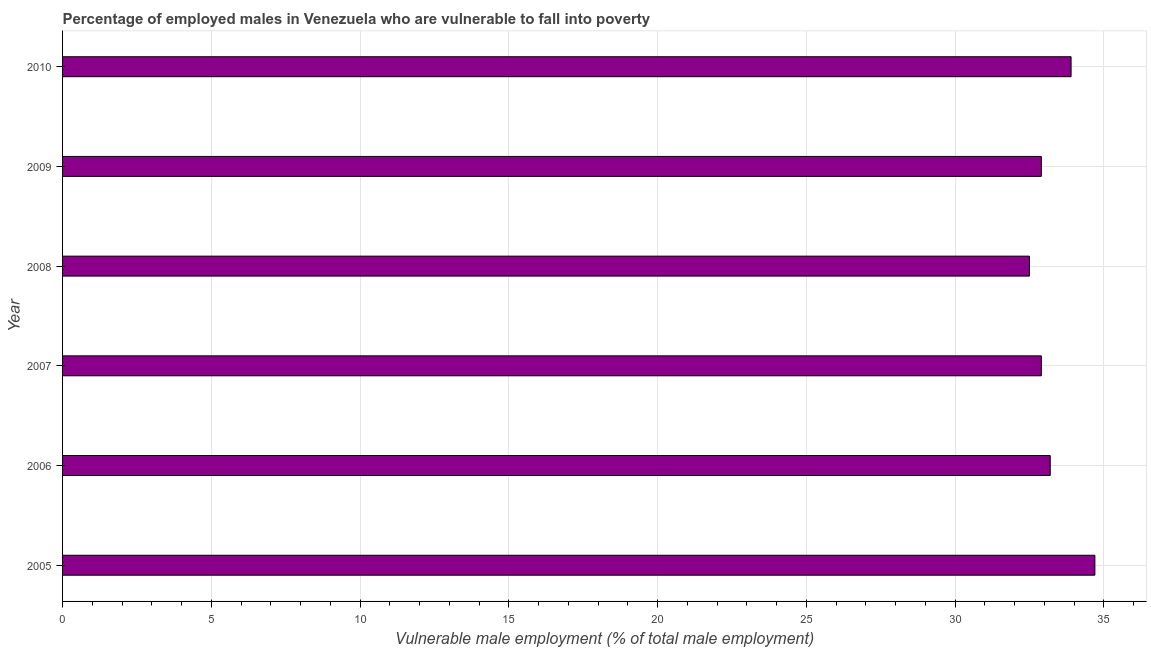Does the graph contain any zero values?
Offer a terse response. No. What is the title of the graph?
Ensure brevity in your answer.  Percentage of employed males in Venezuela who are vulnerable to fall into poverty. What is the label or title of the X-axis?
Provide a succinct answer. Vulnerable male employment (% of total male employment). What is the label or title of the Y-axis?
Provide a short and direct response. Year. What is the percentage of employed males who are vulnerable to fall into poverty in 2010?
Keep it short and to the point. 33.9. Across all years, what is the maximum percentage of employed males who are vulnerable to fall into poverty?
Your answer should be very brief. 34.7. Across all years, what is the minimum percentage of employed males who are vulnerable to fall into poverty?
Your response must be concise. 32.5. In which year was the percentage of employed males who are vulnerable to fall into poverty maximum?
Your response must be concise. 2005. In which year was the percentage of employed males who are vulnerable to fall into poverty minimum?
Give a very brief answer. 2008. What is the sum of the percentage of employed males who are vulnerable to fall into poverty?
Your answer should be compact. 200.1. What is the difference between the percentage of employed males who are vulnerable to fall into poverty in 2006 and 2010?
Provide a succinct answer. -0.7. What is the average percentage of employed males who are vulnerable to fall into poverty per year?
Offer a very short reply. 33.35. What is the median percentage of employed males who are vulnerable to fall into poverty?
Your response must be concise. 33.05. In how many years, is the percentage of employed males who are vulnerable to fall into poverty greater than 21 %?
Your answer should be compact. 6. Do a majority of the years between 2009 and 2007 (inclusive) have percentage of employed males who are vulnerable to fall into poverty greater than 19 %?
Your response must be concise. Yes. Is the difference between the percentage of employed males who are vulnerable to fall into poverty in 2009 and 2010 greater than the difference between any two years?
Give a very brief answer. No. Is the sum of the percentage of employed males who are vulnerable to fall into poverty in 2006 and 2008 greater than the maximum percentage of employed males who are vulnerable to fall into poverty across all years?
Your answer should be very brief. Yes. What is the difference between the highest and the lowest percentage of employed males who are vulnerable to fall into poverty?
Provide a short and direct response. 2.2. In how many years, is the percentage of employed males who are vulnerable to fall into poverty greater than the average percentage of employed males who are vulnerable to fall into poverty taken over all years?
Provide a short and direct response. 2. How many years are there in the graph?
Make the answer very short. 6. What is the difference between two consecutive major ticks on the X-axis?
Offer a very short reply. 5. What is the Vulnerable male employment (% of total male employment) of 2005?
Keep it short and to the point. 34.7. What is the Vulnerable male employment (% of total male employment) of 2006?
Ensure brevity in your answer.  33.2. What is the Vulnerable male employment (% of total male employment) of 2007?
Give a very brief answer. 32.9. What is the Vulnerable male employment (% of total male employment) of 2008?
Offer a very short reply. 32.5. What is the Vulnerable male employment (% of total male employment) in 2009?
Your response must be concise. 32.9. What is the Vulnerable male employment (% of total male employment) of 2010?
Your answer should be very brief. 33.9. What is the difference between the Vulnerable male employment (% of total male employment) in 2005 and 2006?
Provide a short and direct response. 1.5. What is the difference between the Vulnerable male employment (% of total male employment) in 2005 and 2007?
Offer a terse response. 1.8. What is the difference between the Vulnerable male employment (% of total male employment) in 2005 and 2008?
Provide a short and direct response. 2.2. What is the difference between the Vulnerable male employment (% of total male employment) in 2007 and 2008?
Offer a terse response. 0.4. What is the difference between the Vulnerable male employment (% of total male employment) in 2007 and 2010?
Offer a terse response. -1. What is the difference between the Vulnerable male employment (% of total male employment) in 2008 and 2009?
Your answer should be compact. -0.4. What is the difference between the Vulnerable male employment (% of total male employment) in 2008 and 2010?
Your answer should be compact. -1.4. What is the ratio of the Vulnerable male employment (% of total male employment) in 2005 to that in 2006?
Your answer should be very brief. 1.04. What is the ratio of the Vulnerable male employment (% of total male employment) in 2005 to that in 2007?
Make the answer very short. 1.05. What is the ratio of the Vulnerable male employment (% of total male employment) in 2005 to that in 2008?
Make the answer very short. 1.07. What is the ratio of the Vulnerable male employment (% of total male employment) in 2005 to that in 2009?
Provide a short and direct response. 1.05. What is the ratio of the Vulnerable male employment (% of total male employment) in 2007 to that in 2008?
Provide a succinct answer. 1.01. What is the ratio of the Vulnerable male employment (% of total male employment) in 2009 to that in 2010?
Your answer should be compact. 0.97. 